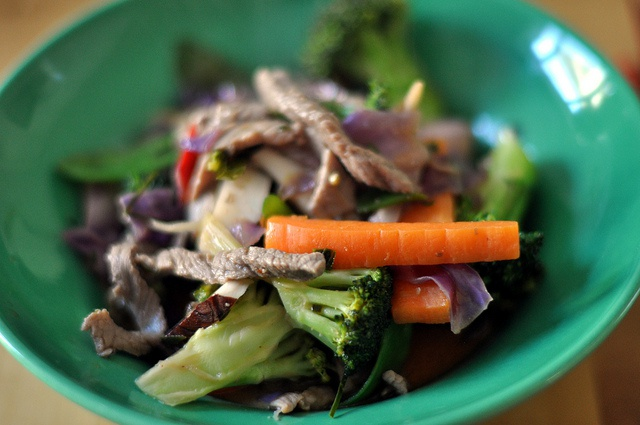Describe the objects in this image and their specific colors. I can see bowl in black, darkgreen, and olive tones, carrot in olive, red, orange, and brown tones, broccoli in olive and black tones, broccoli in olive, black, and darkgreen tones, and broccoli in olive, black, and darkgreen tones in this image. 